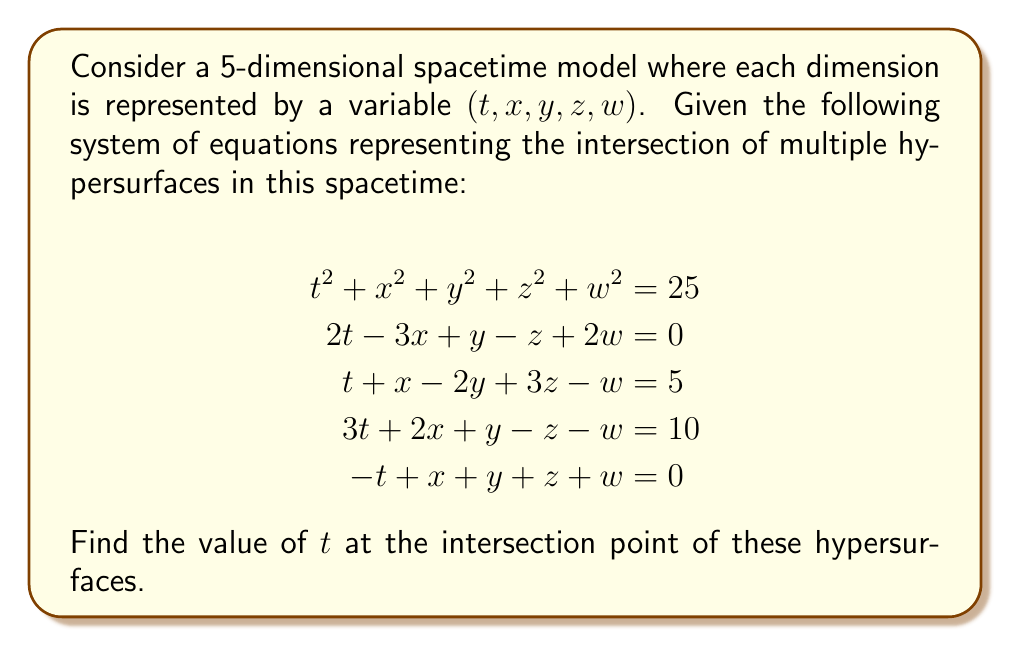Help me with this question. To solve this system of equations, we'll use the Gaussian elimination method:

1) First, let's arrange the equations in matrix form:

$$\begin{bmatrix}
1 & 1 & 1 & 1 & 1 & 25 \\
2 & -3 & 1 & -1 & 2 & 0 \\
1 & 1 & -2 & 3 & -1 & 5 \\
3 & 2 & 1 & -1 & -1 & 10 \\
-1 & 1 & 1 & 1 & 1 & 0
\end{bmatrix}$$

2) Now, we'll perform row operations to get an upper triangular matrix:

$$\begin{bmatrix}
1 & 1 & 1 & 1 & 1 & 25 \\
0 & -5 & -1 & -3 & 0 & -50 \\
0 & 0 & -3 & 2 & -2 & -20 \\
0 & 0 & 0 & -5 & -4 & -65 \\
0 & 0 & 0 & 0 & 1 & 5
\end{bmatrix}$$

3) From the last row, we can see that $w = 5$.

4) Substituting this back into the fourth row:
   $-5z - 4(5) = -65$
   $-5z = -45$
   $z = 9$

5) Substituting $w$ and $z$ into the third row:
   $-3y + 2(9) - 2(5) = -20$
   $-3y + 8 = -20$
   $-3y = -28$
   $y = \frac{28}{3}$

6) Substituting $y$, $z$, and $w$ into the second row:
   $-5x - 1(\frac{28}{3}) - 3(9) + 0 = -50$
   $-5x - \frac{28}{3} - 27 = -50$
   $-5x = -50 + \frac{28}{3} + 27 = -\frac{55}{3}$
   $x = \frac{11}{3}$

7) Finally, substituting all values into the first equation:
   $t^2 + (\frac{11}{3})^2 + (\frac{28}{3})^2 + 9^2 + 5^2 = 25$
   $t^2 + \frac{121}{9} + \frac{784}{9} + 81 + 25 = 25$
   $t^2 = 25 - \frac{905}{9} - 106 = -\frac{934}{9}$
   $t = \pm \frac{\sqrt{934}}{3}$

Since we're dealing with a physical spacetime model, we typically consider the positive solution for the time coordinate.
Answer: $t = \frac{\sqrt{934}}{3}$ 